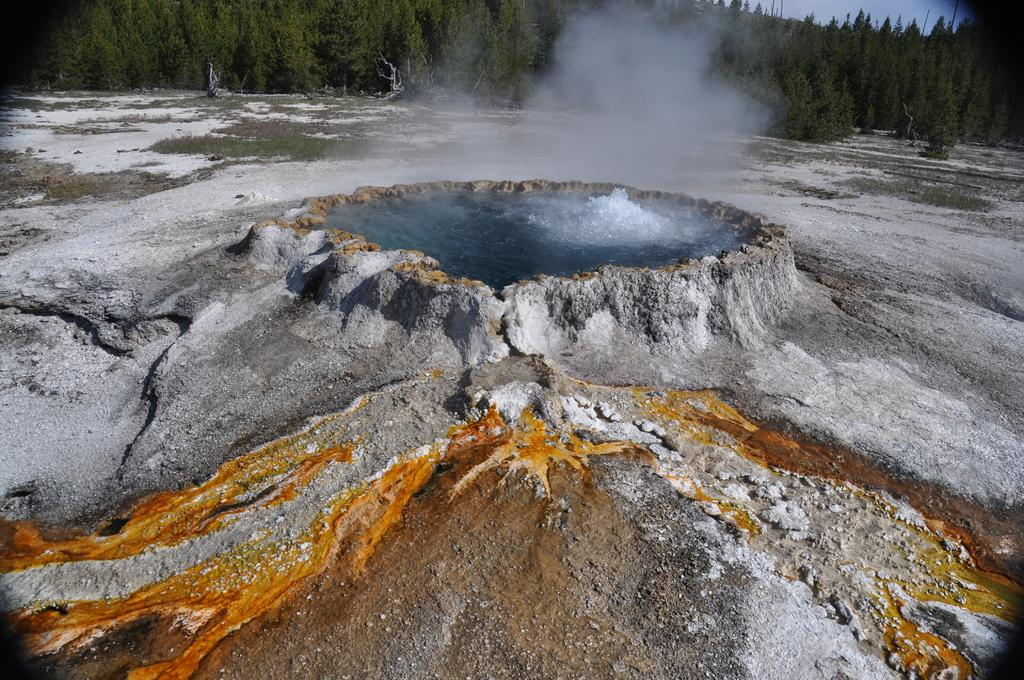What is the main feature in the center of the image? There is a hot spring in the center of the image. What can be seen in the background of the image? There are trees and the sky visible in the background of the image. What type of face can be seen on the hot spring in the image? There is no face present on the hot spring in the image. What kind of paper is being used to fuel the fire in the image? There is no fire or paper present in the image; it features a hot spring and trees in the background. 